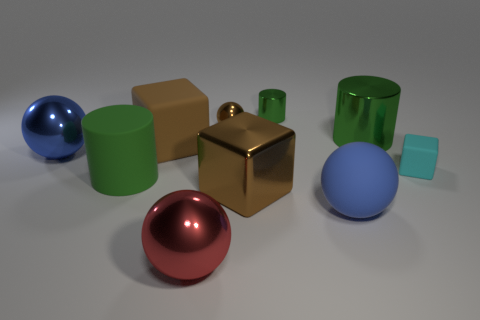Subtract all blocks. How many objects are left? 7 Add 2 large blue metal objects. How many large blue metal objects exist? 3 Subtract 1 red balls. How many objects are left? 9 Subtract all large green cylinders. Subtract all tiny red things. How many objects are left? 8 Add 4 big brown metal cubes. How many big brown metal cubes are left? 5 